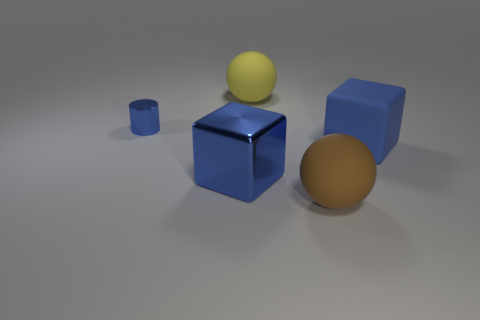Add 3 small yellow matte objects. How many objects exist? 8 Subtract 0 cyan balls. How many objects are left? 5 Subtract all cubes. How many objects are left? 3 Subtract all large blue metallic cubes. Subtract all shiny blocks. How many objects are left? 3 Add 3 brown rubber balls. How many brown rubber balls are left? 4 Add 5 matte spheres. How many matte spheres exist? 7 